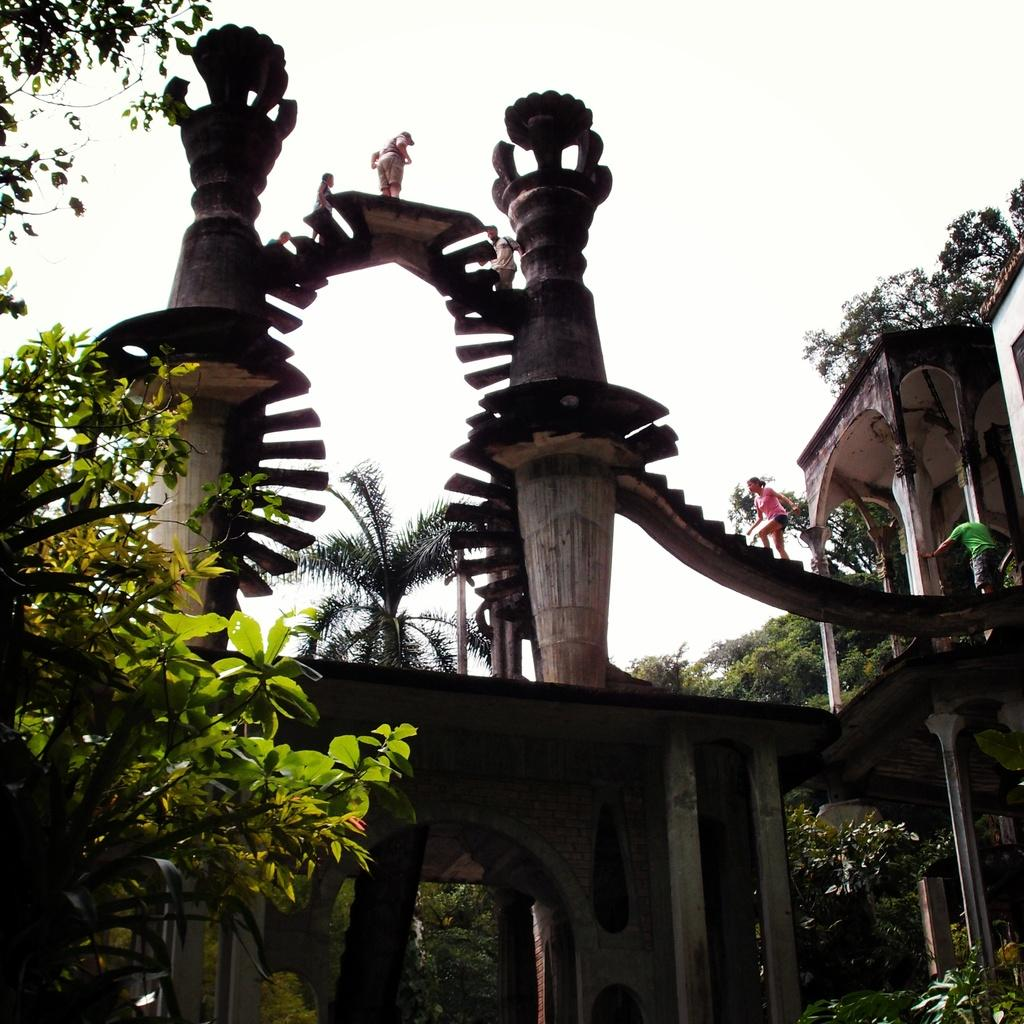What type of structure is present in the image? There is an arch with pillars in the image. Are there any architectural features associated with the arch? Yes, there are stairs associated with the arch. What can be seen on the stairs in the image? There are people standing on the stairs. What type of natural elements are present in the image? There are trees in the image. What is visible in the background of the image? The sky is visible in the background of the image. Can you tell me how many snakes are wrapped around the pillars of the arch in the image? There are no snakes present in the image; the pillars are not associated with any snakes. What type of quilt is being used as a cover for the trees in the image? There is no quilt present in the image, and the trees are not covered by any quilt. 